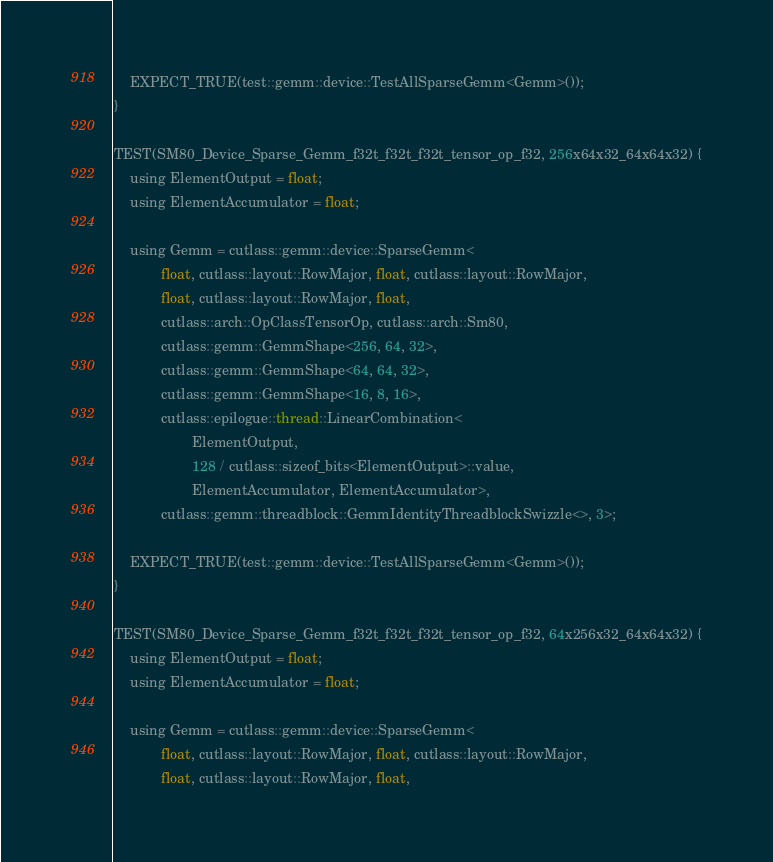Convert code to text. <code><loc_0><loc_0><loc_500><loc_500><_Cuda_>
    EXPECT_TRUE(test::gemm::device::TestAllSparseGemm<Gemm>());
}

TEST(SM80_Device_Sparse_Gemm_f32t_f32t_f32t_tensor_op_f32, 256x64x32_64x64x32) {
    using ElementOutput = float;
    using ElementAccumulator = float;

    using Gemm = cutlass::gemm::device::SparseGemm<
            float, cutlass::layout::RowMajor, float, cutlass::layout::RowMajor,
            float, cutlass::layout::RowMajor, float,
            cutlass::arch::OpClassTensorOp, cutlass::arch::Sm80,
            cutlass::gemm::GemmShape<256, 64, 32>,
            cutlass::gemm::GemmShape<64, 64, 32>,
            cutlass::gemm::GemmShape<16, 8, 16>,
            cutlass::epilogue::thread::LinearCombination<
                    ElementOutput,
                    128 / cutlass::sizeof_bits<ElementOutput>::value,
                    ElementAccumulator, ElementAccumulator>,
            cutlass::gemm::threadblock::GemmIdentityThreadblockSwizzle<>, 3>;

    EXPECT_TRUE(test::gemm::device::TestAllSparseGemm<Gemm>());
}

TEST(SM80_Device_Sparse_Gemm_f32t_f32t_f32t_tensor_op_f32, 64x256x32_64x64x32) {
    using ElementOutput = float;
    using ElementAccumulator = float;

    using Gemm = cutlass::gemm::device::SparseGemm<
            float, cutlass::layout::RowMajor, float, cutlass::layout::RowMajor,
            float, cutlass::layout::RowMajor, float,</code> 